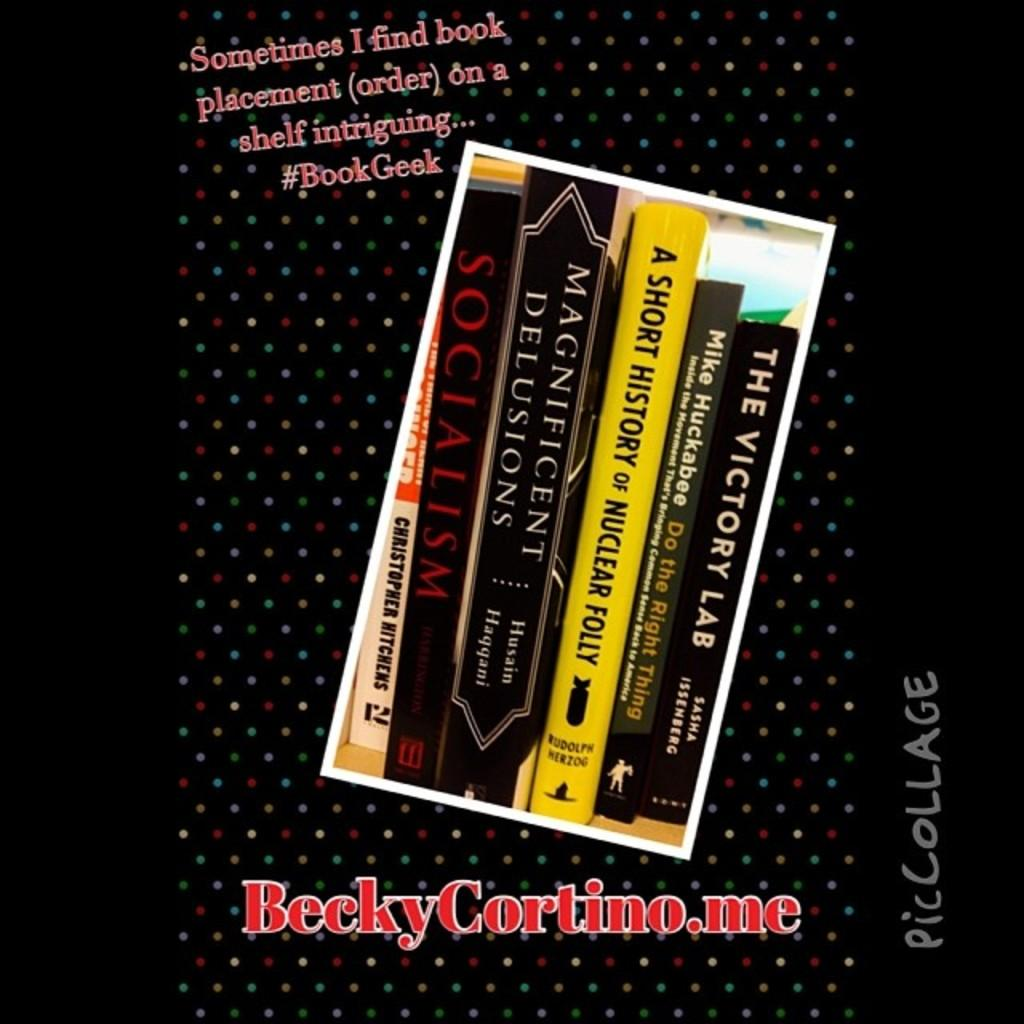Provide a one-sentence caption for the provided image. the book cover showing six books of socialism, nuclear folly, victory lab. 